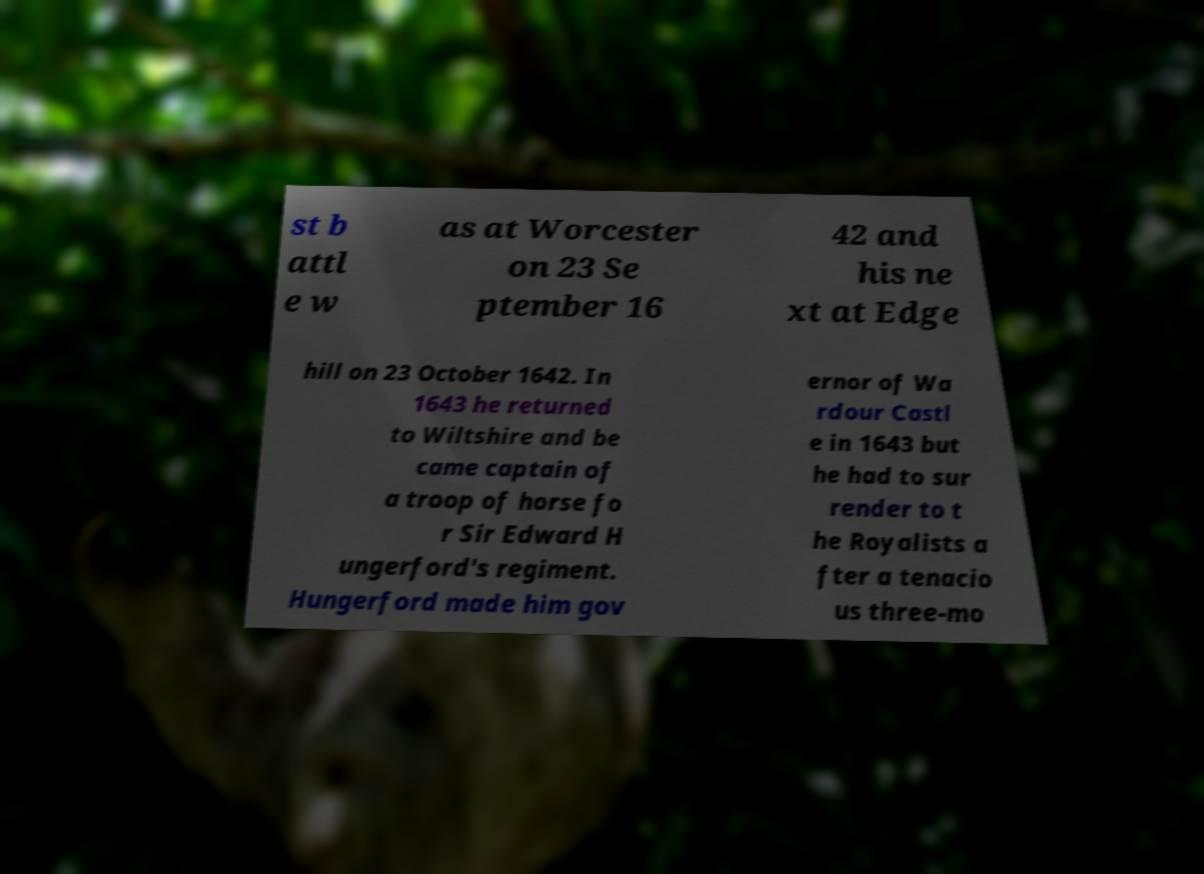I need the written content from this picture converted into text. Can you do that? st b attl e w as at Worcester on 23 Se ptember 16 42 and his ne xt at Edge hill on 23 October 1642. In 1643 he returned to Wiltshire and be came captain of a troop of horse fo r Sir Edward H ungerford's regiment. Hungerford made him gov ernor of Wa rdour Castl e in 1643 but he had to sur render to t he Royalists a fter a tenacio us three-mo 